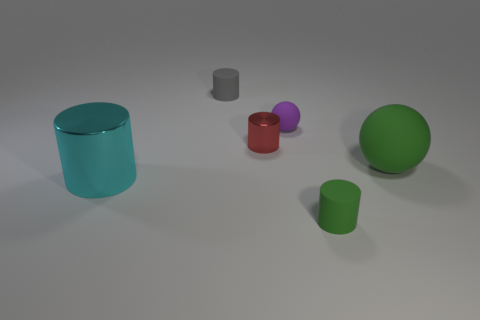What number of metal cylinders have the same size as the purple thing?
Your response must be concise. 1. What number of metallic objects are small gray objects or purple things?
Provide a short and direct response. 0. What is the cyan cylinder made of?
Make the answer very short. Metal. There is a big green object; what number of large green spheres are behind it?
Offer a terse response. 0. Is the material of the ball that is to the left of the small green cylinder the same as the cyan thing?
Provide a succinct answer. No. How many red shiny things have the same shape as the tiny gray thing?
Your answer should be compact. 1. What number of small things are either purple balls or purple metallic objects?
Give a very brief answer. 1. There is a matte object on the left side of the small red object; does it have the same color as the small metallic object?
Your response must be concise. No. Is the color of the small thing in front of the big green rubber thing the same as the matte cylinder behind the large cyan thing?
Offer a very short reply. No. Are there any tiny red cylinders that have the same material as the large cylinder?
Provide a short and direct response. Yes. 